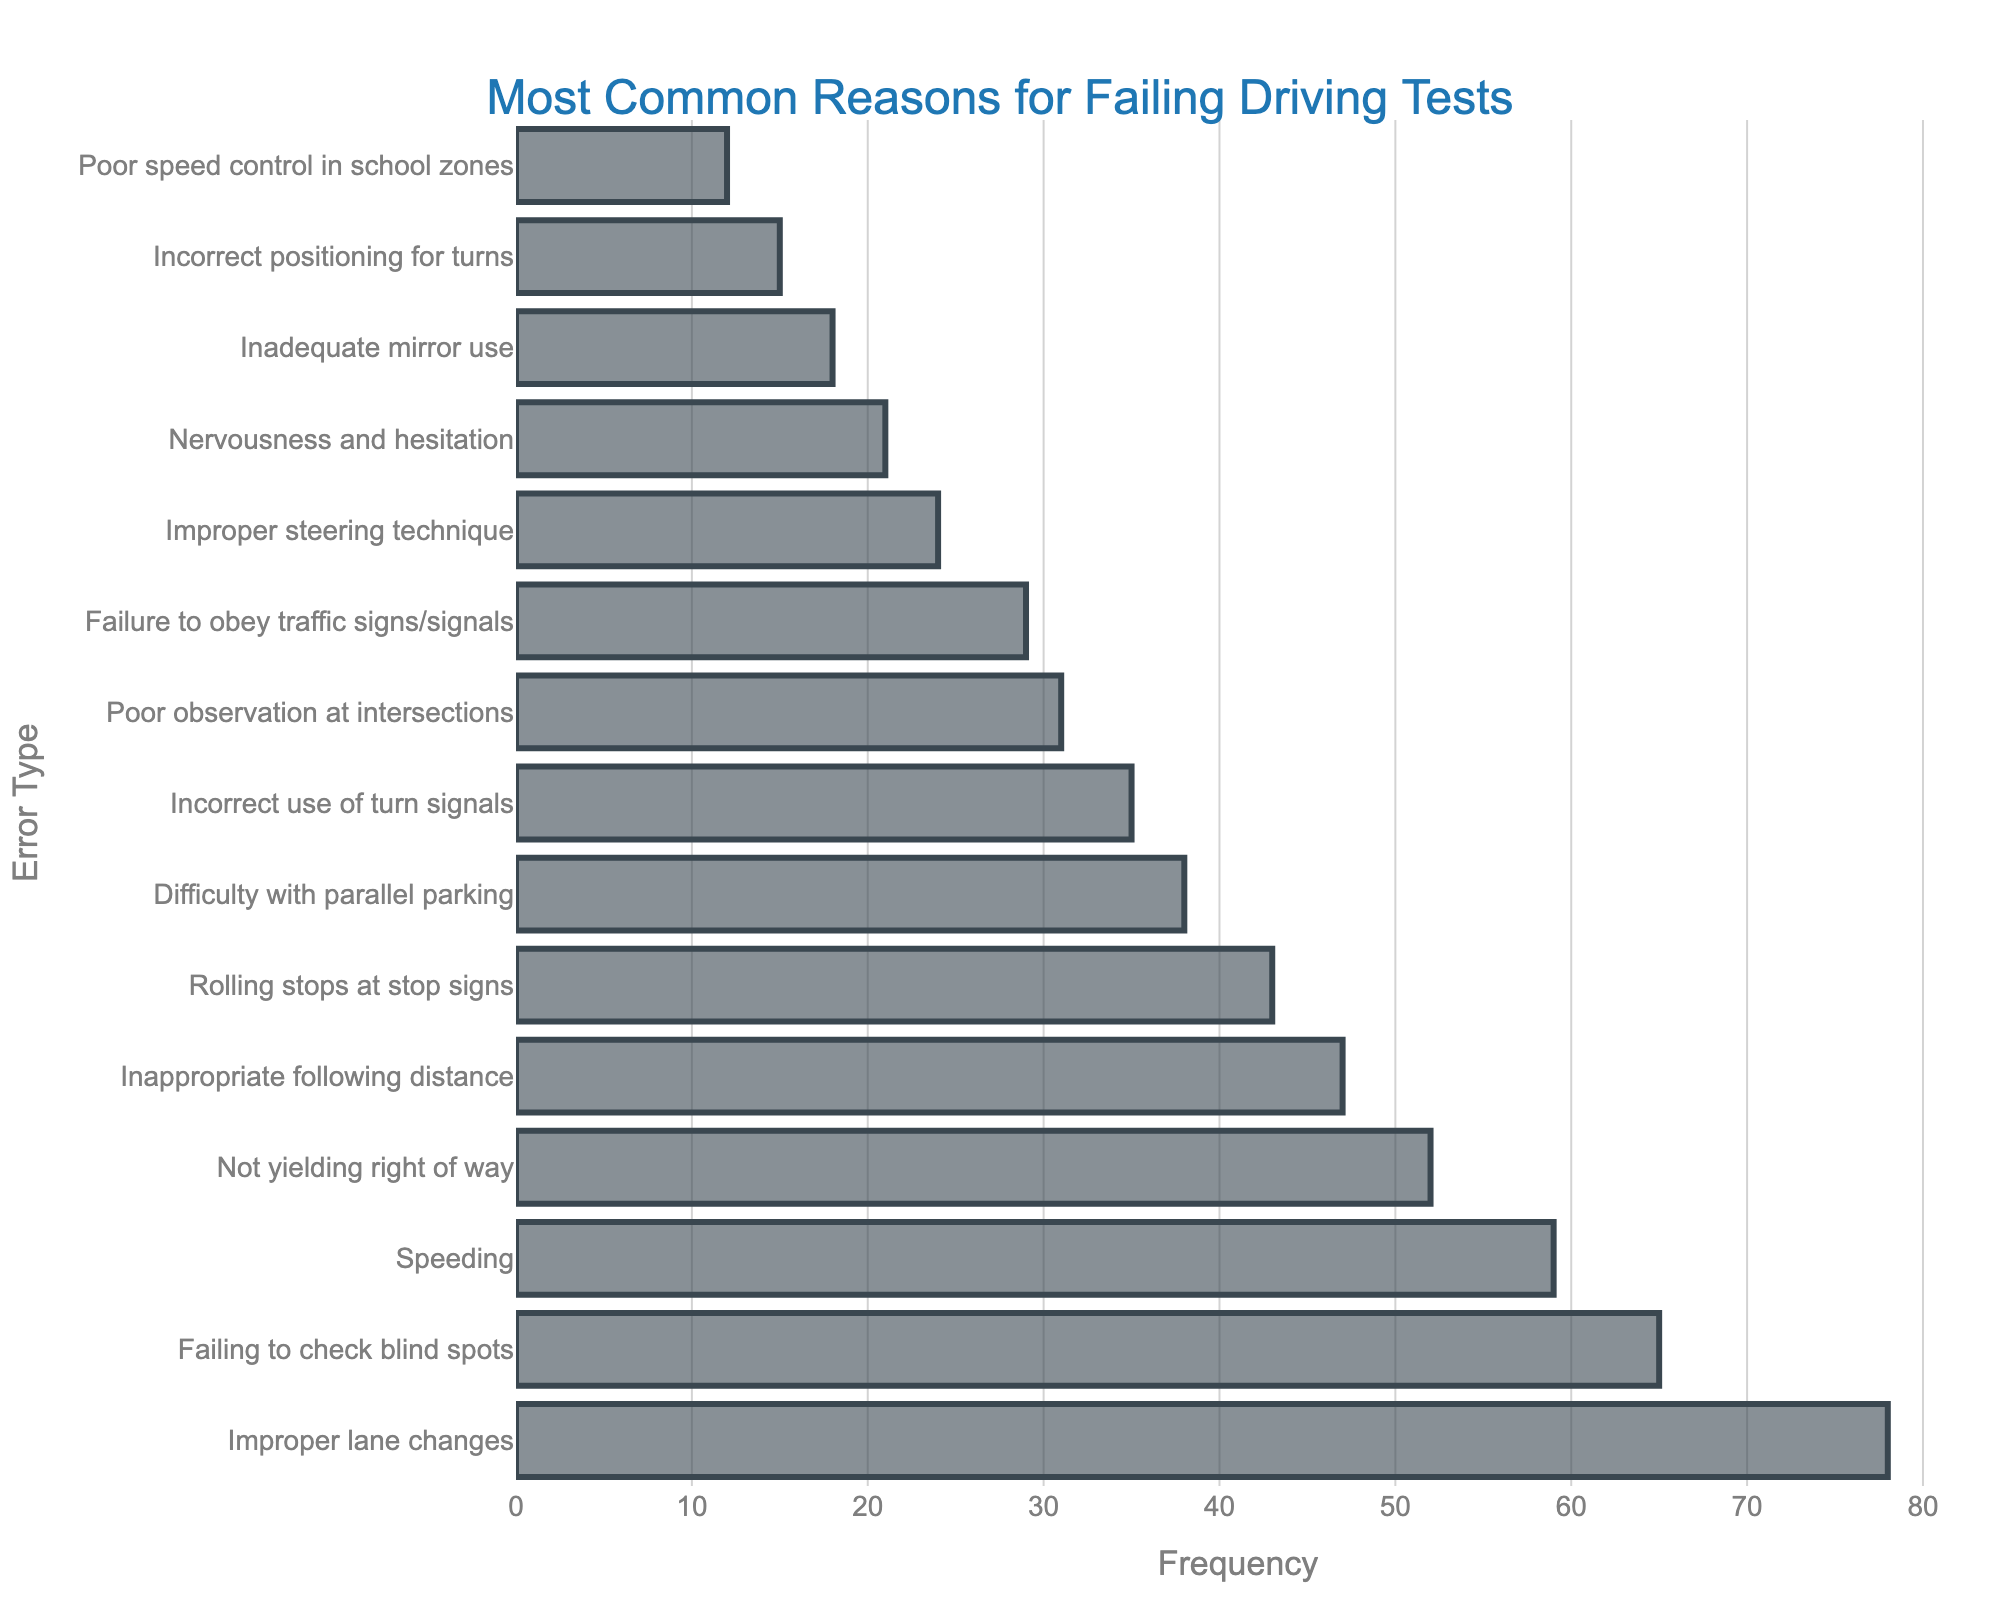Which error type has the highest frequency? Look at the bar with the greatest length. The longest bar corresponds to "Improper lane changes", which has a frequency of 78.
Answer: Improper lane changes What's the total frequency for "Speeding" and "Not yielding right of way"? Identify the frequency for each error type and add them together. Speeding has a frequency of 59 and Not yielding right of way has 52. Adding them gives 59 + 52 = 111.
Answer: 111 How many error types have a frequency greater than 50? Count the number of bars with frequencies greater than 50. The error types are: "Improper lane changes" (78), "Failing to check blind spots" (65), "Speeding" (59), and "Not yielding right of way" (52). There are 4 such error types.
Answer: 4 Which has a higher frequency: "Rolling stops at stop signs" or "Difficulty with parallel parking"? Compare the lengths of the two bars. The bar for Rolling stops at stop signs is longer with a frequency of 43, while the bar for Difficulty with parallel parking has a frequency of 38.
Answer: Rolling stops at stop signs What is the difference in frequency between "Inadequate mirror use" and "Nervousness and hesitation"? Subtract the frequency of Nervousness and hesitation from the frequency of Inadequate mirror use: 21 - 18 = 3.
Answer: 3 What is the median frequency of the error types? First, list all the frequencies in ascending order: 12, 15, 18, 21, 24, 29, 31, 35, 38, 43, 47, 52, 59, 65, 78. The median value is the middle number in this ordered list, which is the 8th value: 35.
Answer: 35 Compare the combined frequency of "Poor observation at intersections" and "Failure to obey traffic signs/signals" with "Improper lane changes". Which one is higher? Sum the frequencies of Poor observation at intersections (31) and Failure to obey traffic signs/signals (29), giving 31 + 29 = 60. Compare this with the frequency of Improper lane changes (78). 60 is less than 78.
Answer: Improper lane changes What percentage of the total errors is represented by "Incorrect use of turn signals"? First, find the sum of all frequencies: 78 + 65 + 59 + 52 + 47 + 43 + 38 + 35 + 31 + 29 + 24 + 21 + 18 + 15 + 12 = 567. Then, calculate the percentage for Incorrect use of turn signals (35): (35 / 567) * 100 ≈ 6.17%.
Answer: 6.17% Among the given error types, which one has a frequency closest to the average frequency? Calculate the average frequency: 567 total frequency / 15 error types = 37.8. The frequency closest to 37.8 is for Difficulty with parallel parking (38).
Answer: Difficulty with parallel parking 